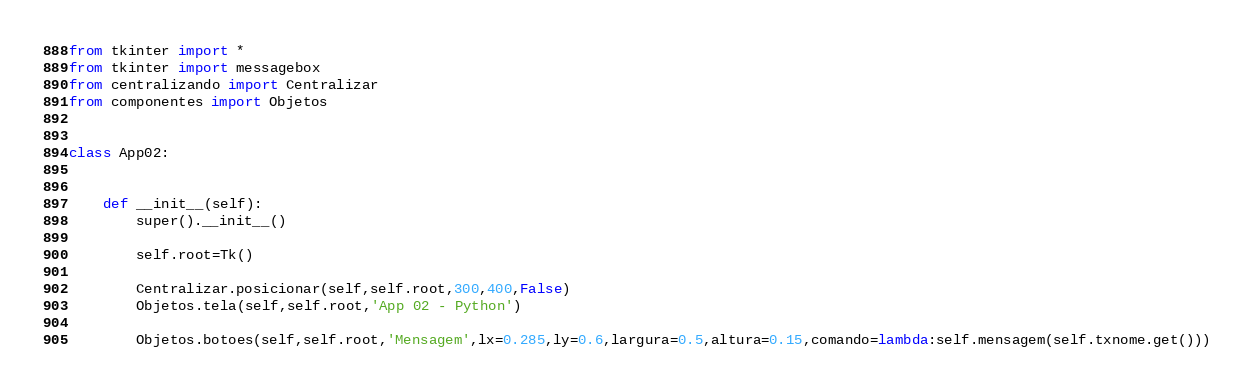<code> <loc_0><loc_0><loc_500><loc_500><_Python_>from tkinter import *
from tkinter import messagebox
from centralizando import Centralizar
from componentes import Objetos


class App02:


    def __init__(self):
        super().__init__()

        self.root=Tk()

        Centralizar.posicionar(self,self.root,300,400,False)
        Objetos.tela(self,self.root,'App 02 - Python')

        Objetos.botoes(self,self.root,'Mensagem',lx=0.285,ly=0.6,largura=0.5,altura=0.15,comando=lambda:self.mensagem(self.txnome.get()))</code> 